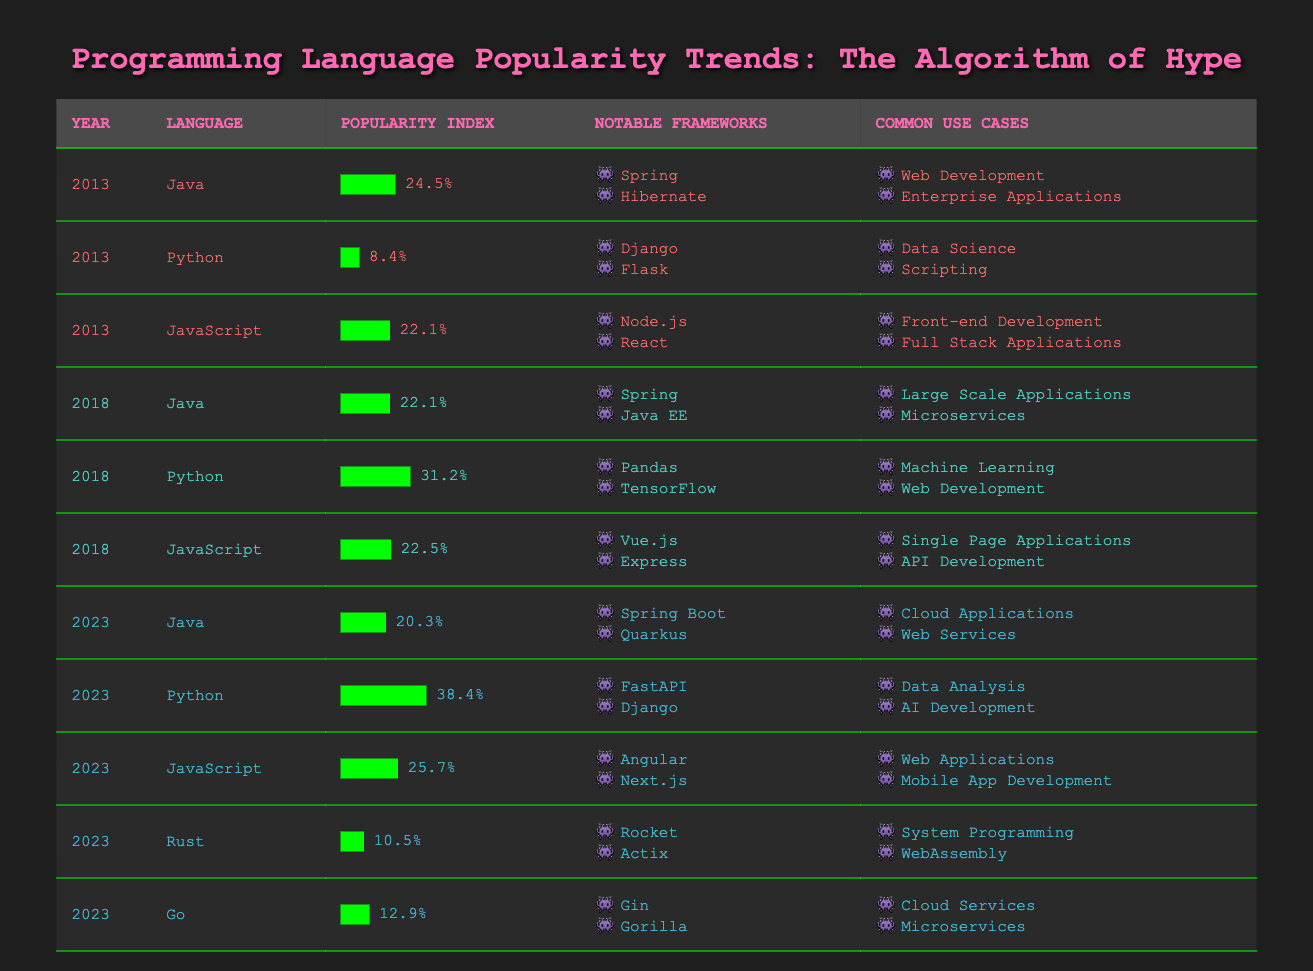What was the popularity index of Python in 2023? In the table, I check the row for Python in 2023, which lists its popularity index as 38.4.
Answer: 38.4 Which programming language had the highest popularity index in 2018? In 2018, the table shows Python with a popularity index of 31.2, which is higher than Java at 22.1 and JavaScript at 22.5. Therefore, Python had the highest popularity index in that year.
Answer: Python Did Java's popularity index increase from 2013 to 2018? In 2013, Java had a popularity index of 24.5, and by 2018, it dropped to 22.1. This indicates a decrease in popularity.
Answer: No What are the notable frameworks associated with JavaScript in 2023? Looking at the row for JavaScript in 2023, the notable frameworks listed are Angular and Next.js.
Answer: Angular, Next.js What is the average popularity index of the programming languages in 2023? The table shows the popularity indexes for various languages in 2023 as follows: Java (20.3), Python (38.4), JavaScript (25.7), Rust (10.5), and Go (12.9). The sum is 20.3 + 38.4 + 25.7 + 10.5 + 12.9 = 117.8. There are 5 languages, so the average is 117.8 / 5 = 23.56.
Answer: 23.56 Which language showed a significant popularity increase from 2013 to 2023? From the data, I see Python increased from 8.4 in 2013 to 38.4 in 2023, which is a notable increase compared to other languages also listed in the earlier year.
Answer: Python Was there any programming language in 2023 that had a popularity index below 15? Checking the table, Rust has 10.5, and Go has 12.9, both below 15.
Answer: Yes In what year did JavaScript have a higher popularity index, 2018 or 2023? From the table, JavaScript had a popularity index of 22.5 in 2018 and 25.7 in 2023. Comparing these values, JavaScript was more popular in 2023.
Answer: 2023 What is the difference in popularity index between Java and Python in 2023? In 2023, Java has a popularity index of 20.3, and Python has 38.4. The difference is calculated by subtracting Java's index from Python's: 38.4 - 20.3 = 18.1.
Answer: 18.1 